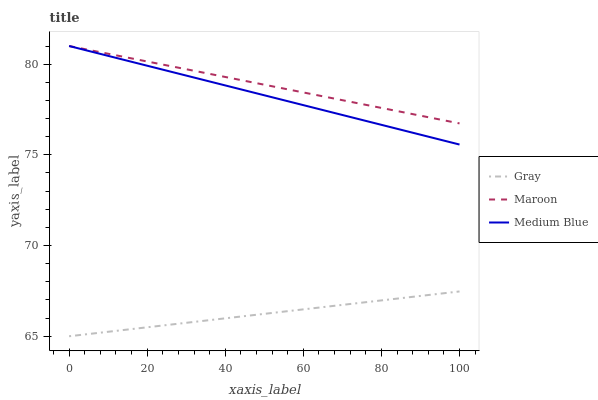Does Gray have the minimum area under the curve?
Answer yes or no. Yes. Does Maroon have the maximum area under the curve?
Answer yes or no. Yes. Does Medium Blue have the minimum area under the curve?
Answer yes or no. No. Does Medium Blue have the maximum area under the curve?
Answer yes or no. No. Is Maroon the smoothest?
Answer yes or no. Yes. Is Gray the roughest?
Answer yes or no. Yes. Is Medium Blue the smoothest?
Answer yes or no. No. Is Medium Blue the roughest?
Answer yes or no. No. Does Medium Blue have the lowest value?
Answer yes or no. No. Does Maroon have the highest value?
Answer yes or no. Yes. Is Gray less than Medium Blue?
Answer yes or no. Yes. Is Medium Blue greater than Gray?
Answer yes or no. Yes. Does Medium Blue intersect Maroon?
Answer yes or no. Yes. Is Medium Blue less than Maroon?
Answer yes or no. No. Is Medium Blue greater than Maroon?
Answer yes or no. No. Does Gray intersect Medium Blue?
Answer yes or no. No. 